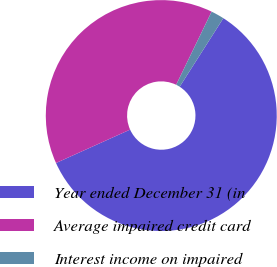Convert chart. <chart><loc_0><loc_0><loc_500><loc_500><pie_chart><fcel>Year ended December 31 (in<fcel>Average impaired credit card<fcel>Interest income on impaired<nl><fcel>59.22%<fcel>38.92%<fcel>1.85%<nl></chart> 